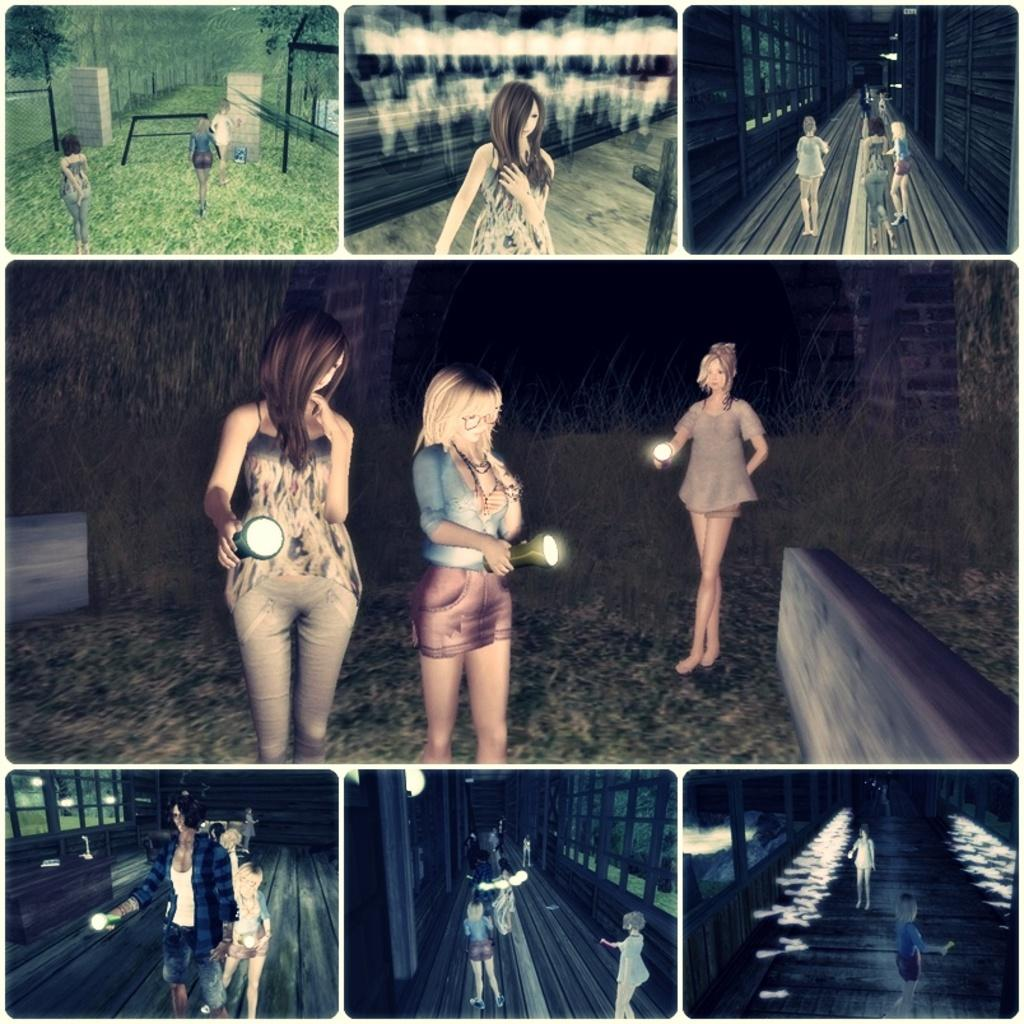What is the main subject of the image? The main subject of the image is a collage of pictures. What else can be seen in the image besides the collage? There are people standing on the ground in the image, and there are women holding torches in their hands. What type of dress is the woman wearing while gripping the torch in the image? There is no woman wearing a dress in the image; the women holding torches are not described as wearing dresses. 